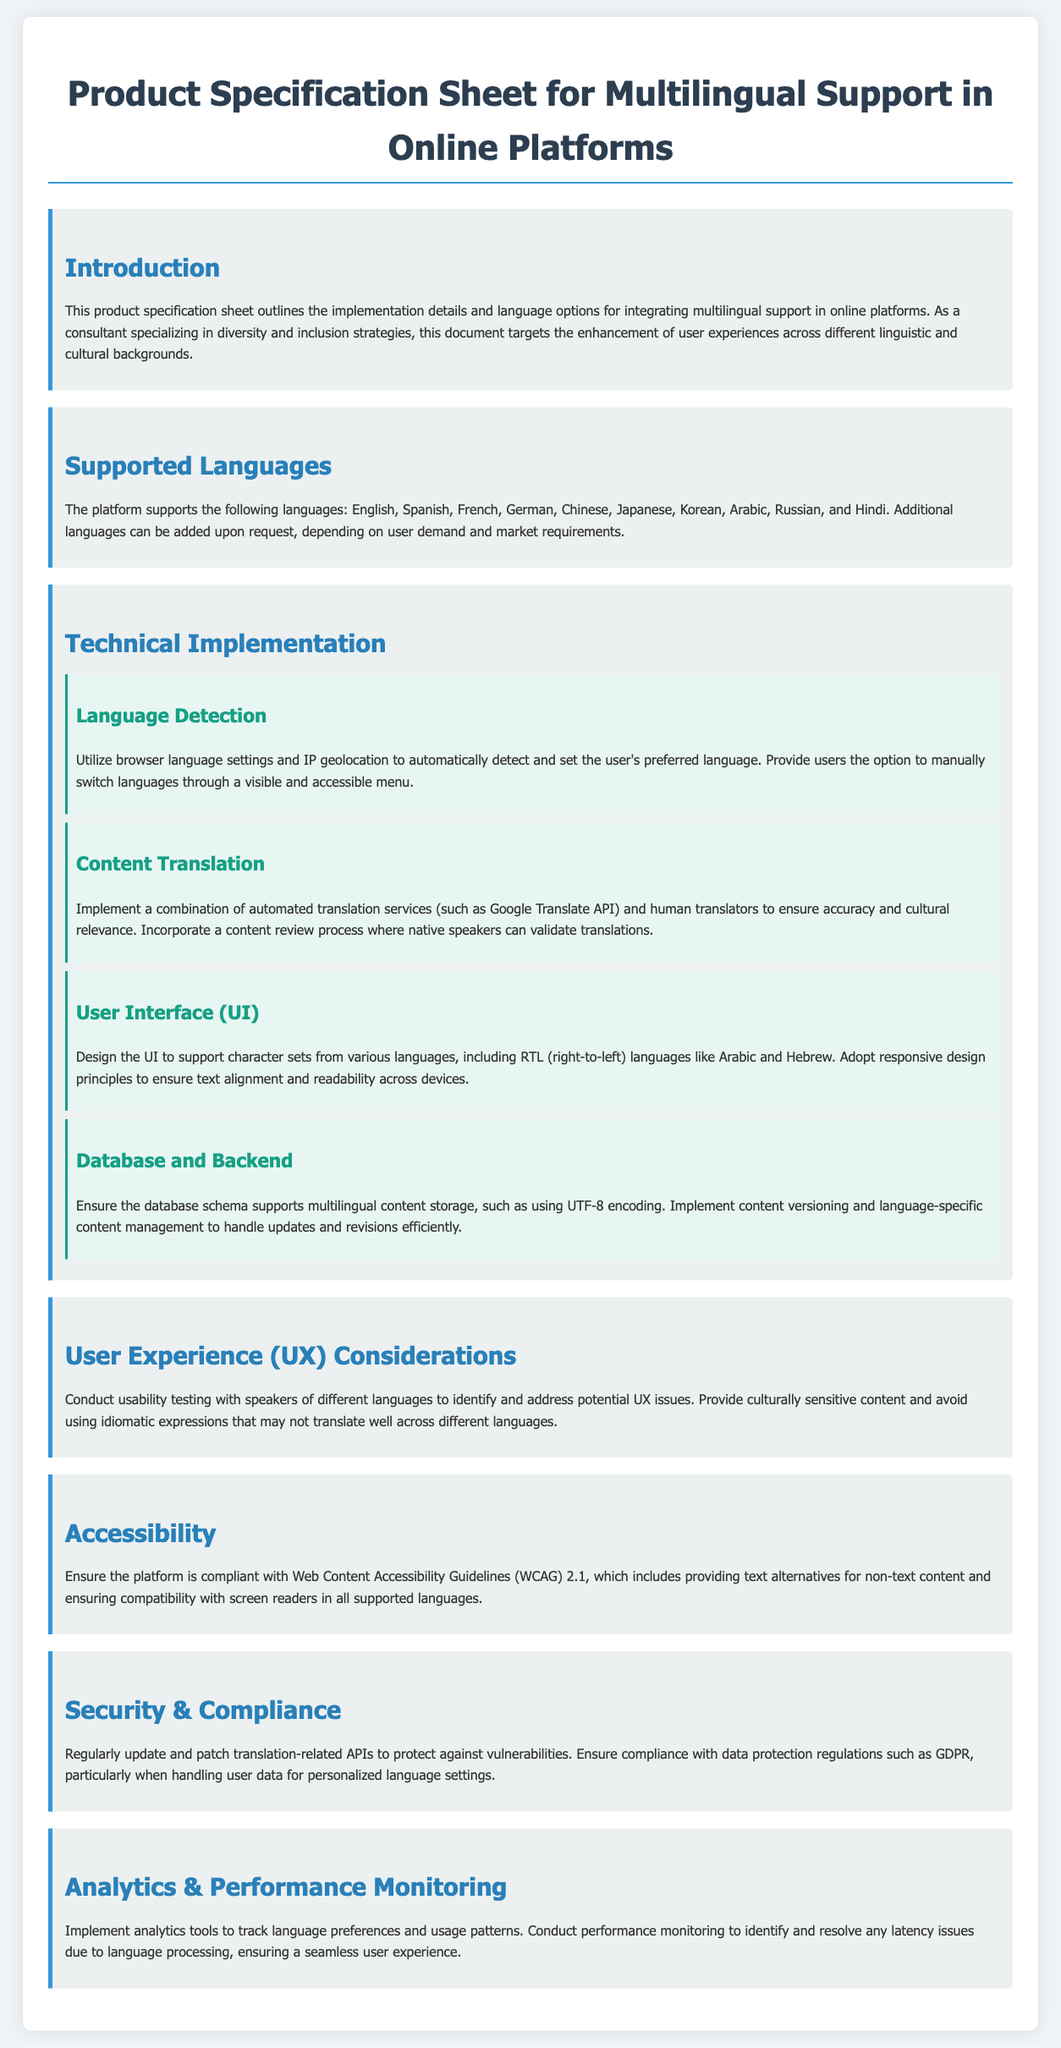what languages are supported by the platform? The supported languages are listed in the document under the "Supported Languages" section.
Answer: English, Spanish, French, German, Chinese, Japanese, Korean, Arabic, Russian, and Hindi how can users switch languages? The method for switching languages is explained in the "Language Detection" subsection of the "Technical Implementation" section.
Answer: Through a visible and accessible menu what is the primary consideration for content translation? The content translation method combines various approaches as mentioned in the "Content Translation" subsection.
Answer: Automated translation services and human translators which accessibility guidelines does the platform comply with? The compliance requirement is specified in the "Accessibility" section of the document.
Answer: Web Content Accessibility Guidelines (WCAG) 2.1 how is multilingual content stored in the database? The details of the database approach are mentioned in the "Database and Backend" subsection.
Answer: Using UTF-8 encoding what method is recommended for understanding UX issues? The UX improvement method is outlined in the "User Experience (UX) Considerations" section.
Answer: Usability testing with speakers of different languages how often should translation-related APIs be updated? The regularity of updates is mentioned in the "Security & Compliance" section.
Answer: Regularly 